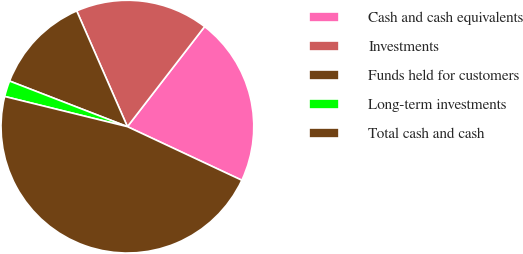<chart> <loc_0><loc_0><loc_500><loc_500><pie_chart><fcel>Cash and cash equivalents<fcel>Investments<fcel>Funds held for customers<fcel>Long-term investments<fcel>Total cash and cash<nl><fcel>21.51%<fcel>17.03%<fcel>12.55%<fcel>2.04%<fcel>46.86%<nl></chart> 